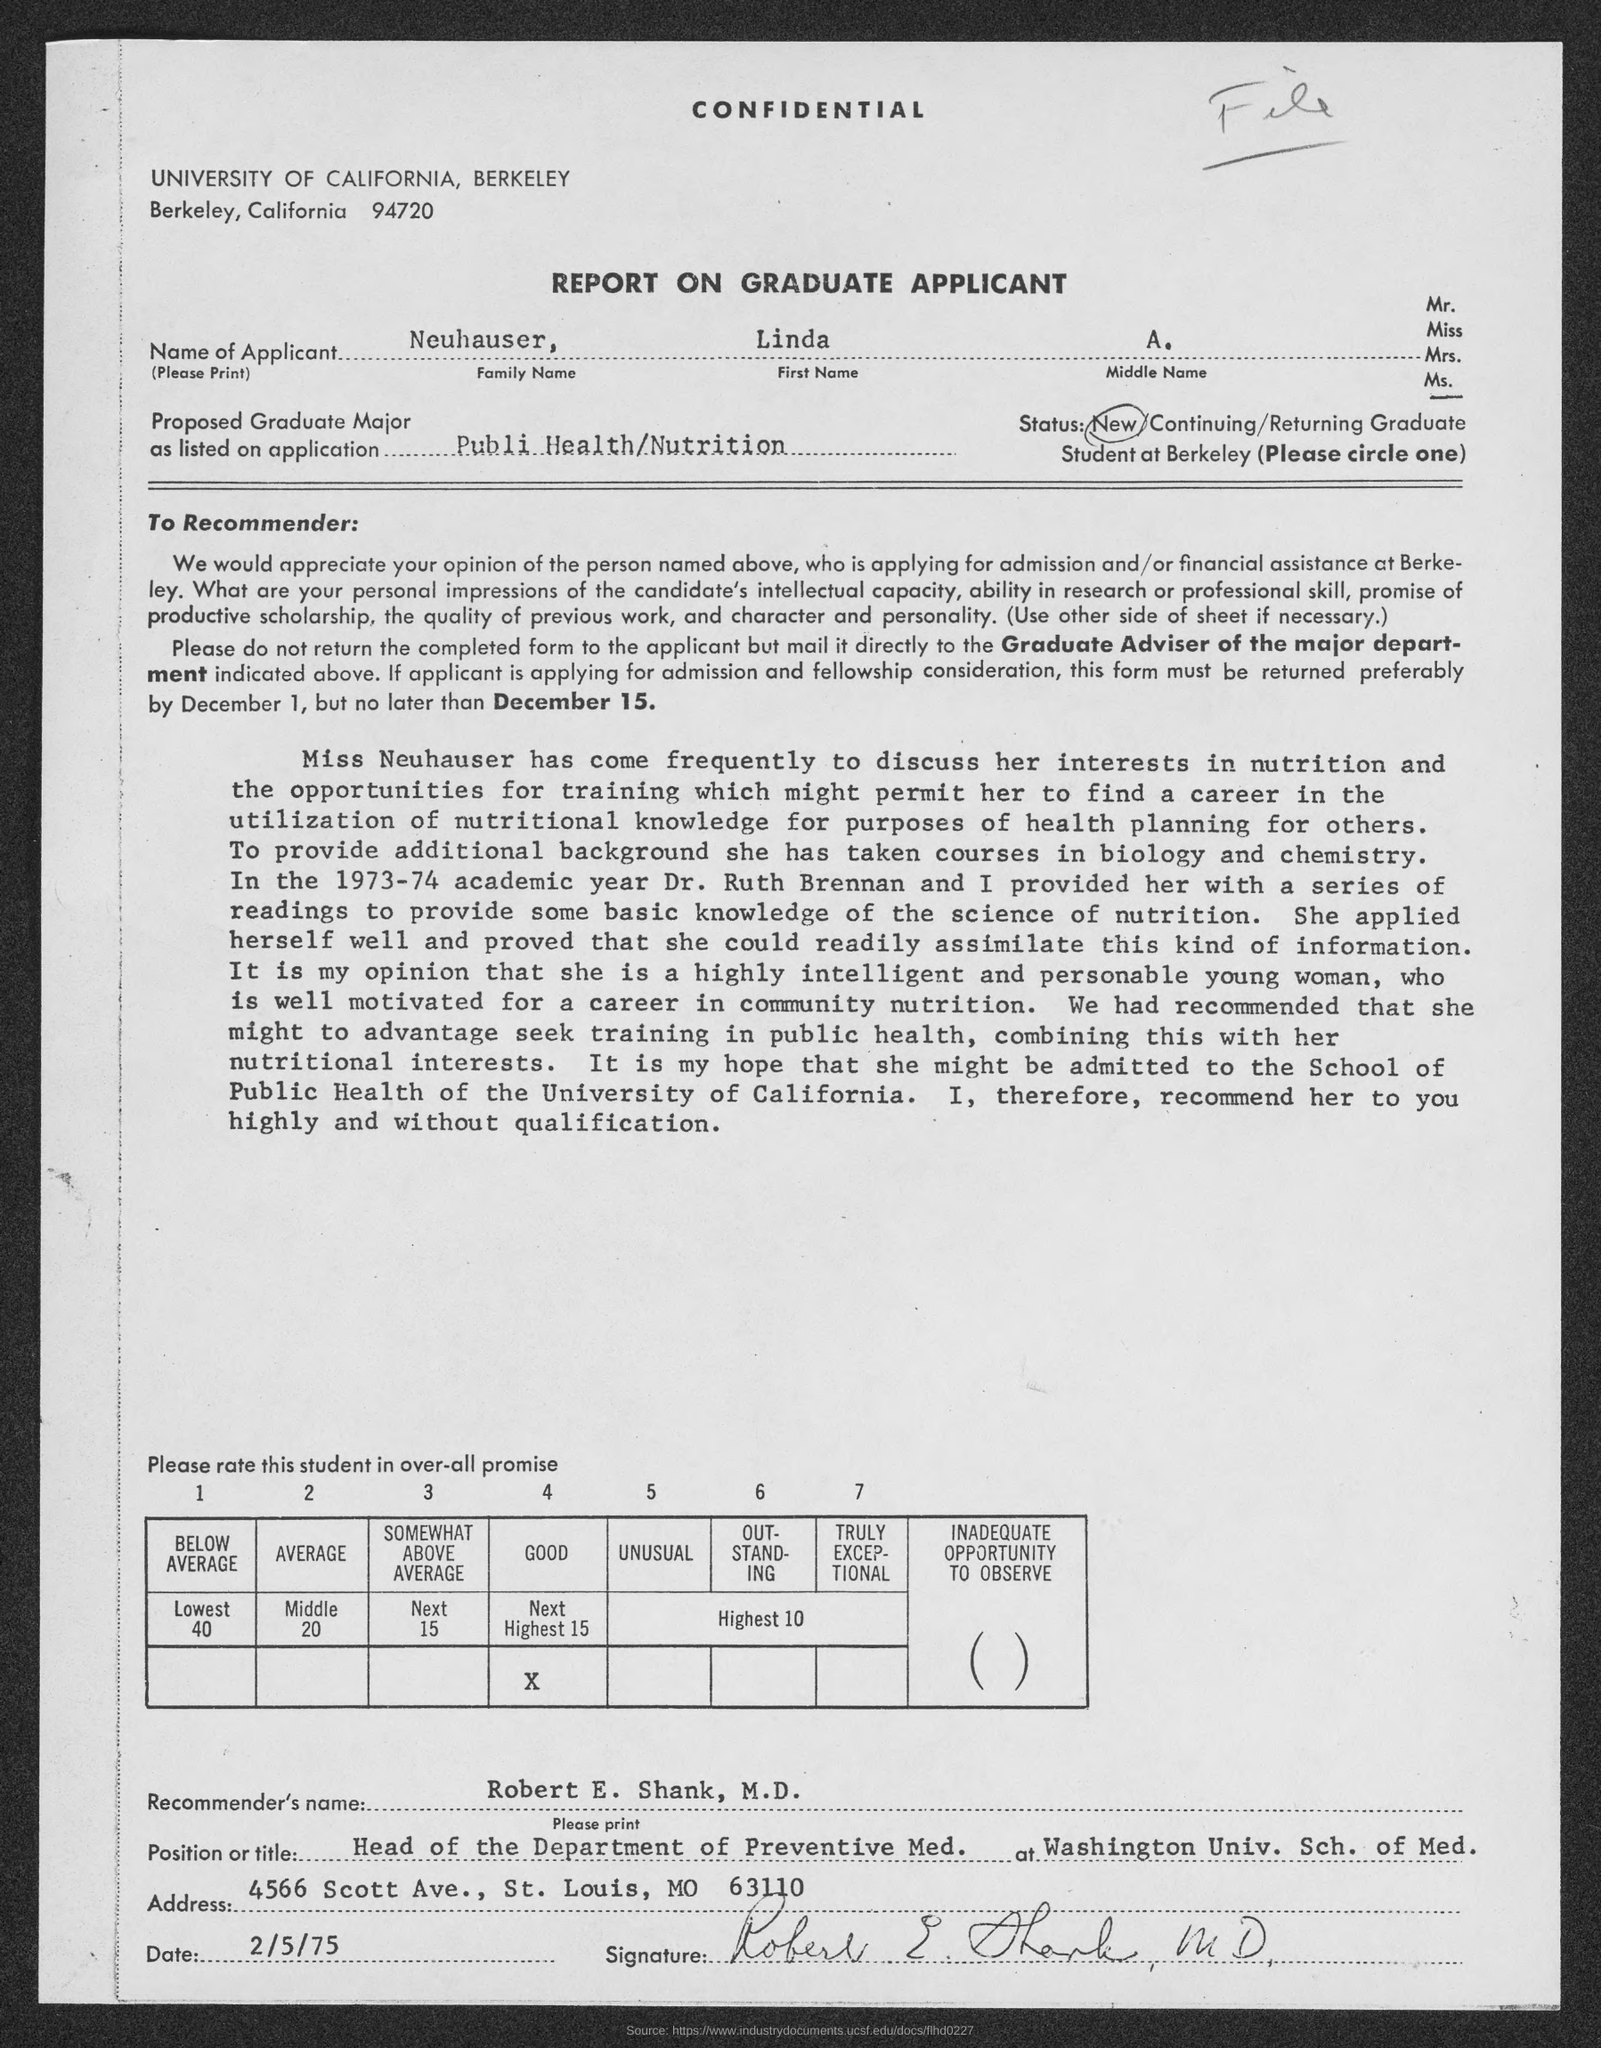What is the name of the applicant?
Provide a succinct answer. Neuhauser, Linda, A. What is the Recommender's name given in the application?
Your response must be concise. Robert E. Shank,  M.D. 